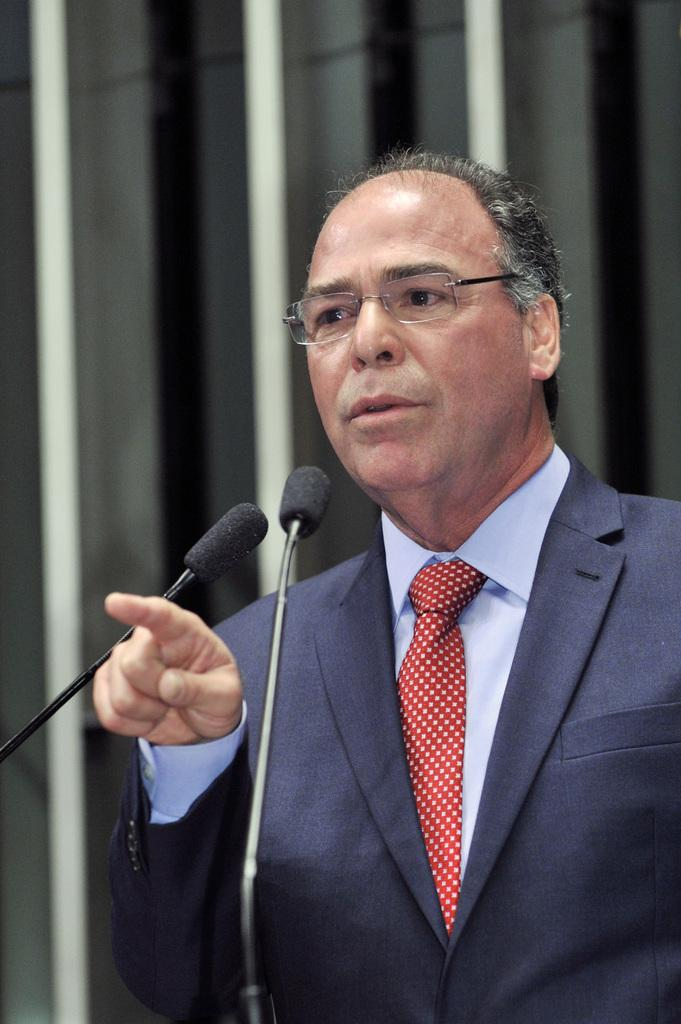What is the main subject of the image? There is a person in the image. What can be observed about the person's appearance? The person is wearing spectacles. What activity is the person engaged in? The person is talking in front of a microphone. How many apples are being carried in the pail by the person in the image? There are no apples or pail present in the image. What type of selection process is the person conducting in the image? There is no selection process depicted in the image; the person is talking in front of a microphone. 